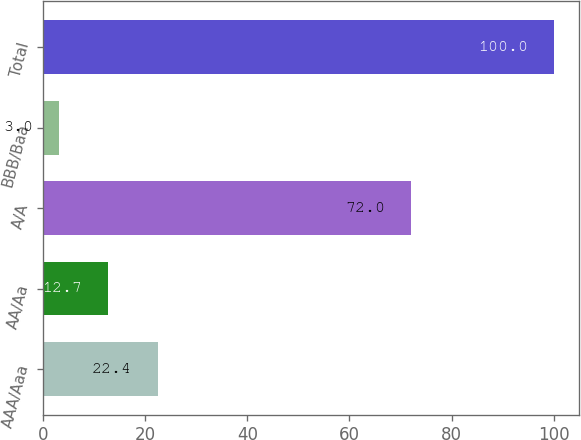Convert chart to OTSL. <chart><loc_0><loc_0><loc_500><loc_500><bar_chart><fcel>AAA/Aaa<fcel>AA/Aa<fcel>A/A<fcel>BBB/Baa<fcel>Total<nl><fcel>22.4<fcel>12.7<fcel>72<fcel>3<fcel>100<nl></chart> 